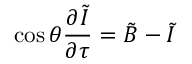Convert formula to latex. <formula><loc_0><loc_0><loc_500><loc_500>\cos \theta \frac { \partial \tilde { I } } { \partial \tau } = \tilde { B } - \tilde { I }</formula> 